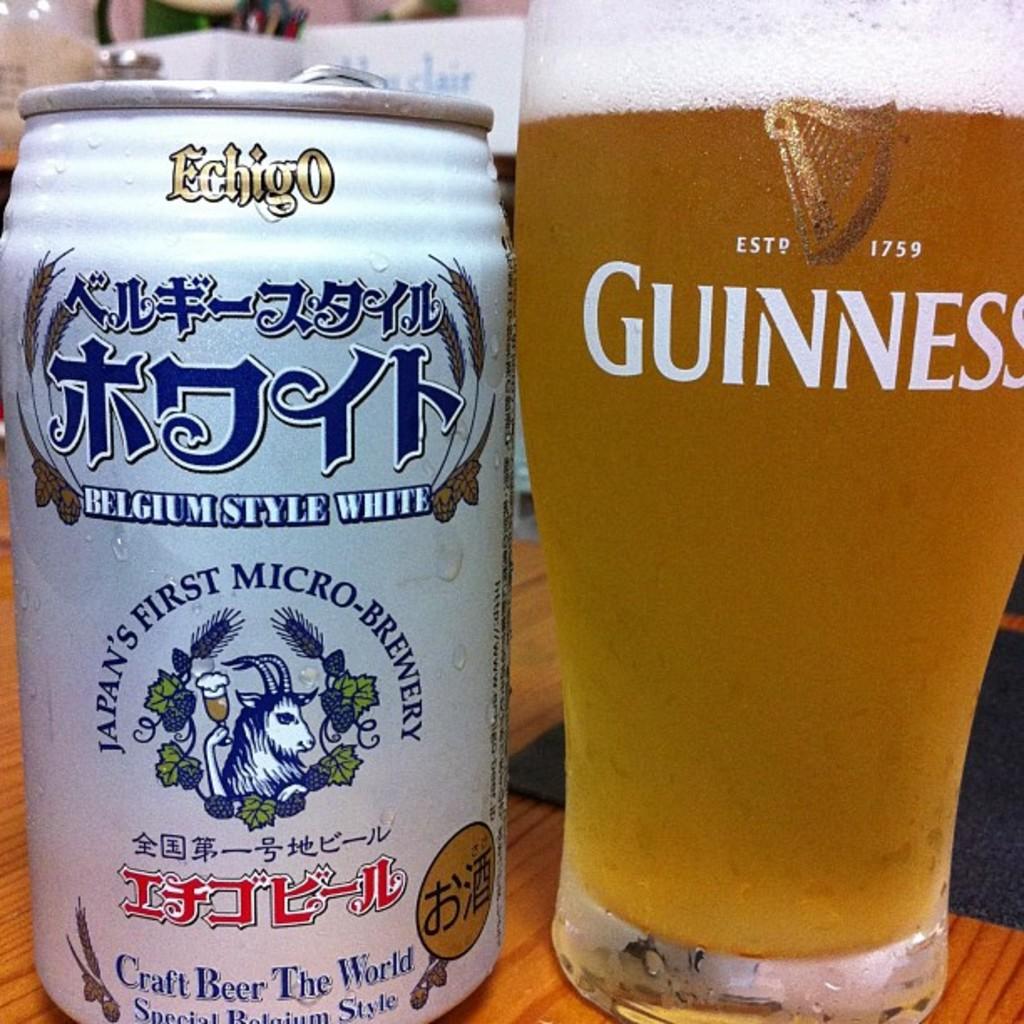What style of beer is shown in the can on the left?
Keep it short and to the point. Belgium style white. What brand name is on the glass on tright?
Keep it short and to the point. Guinness. 